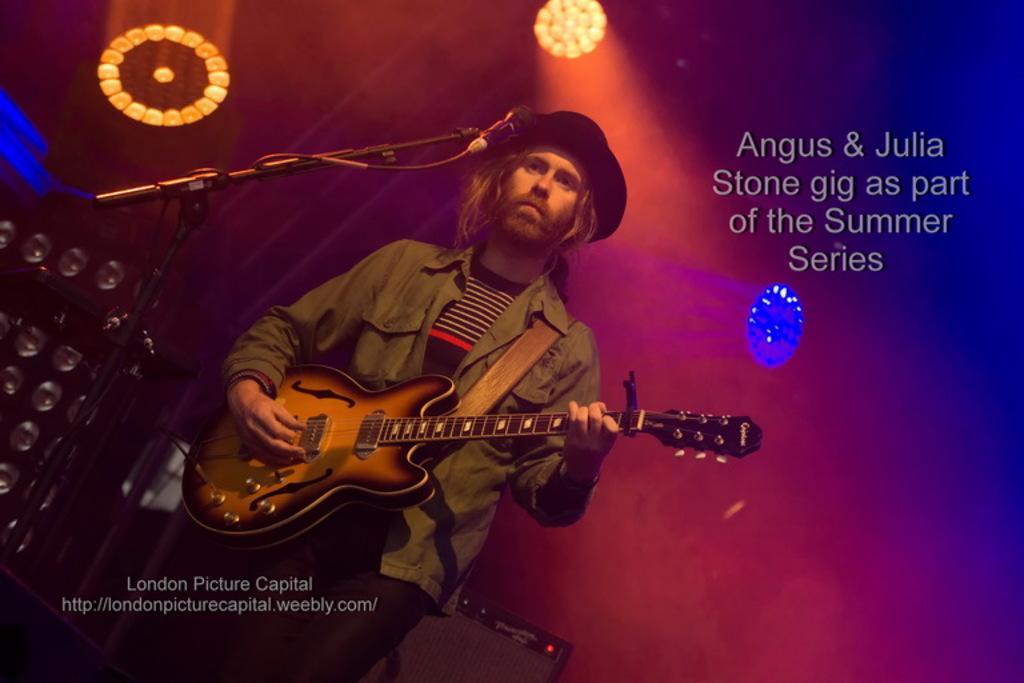Describe this image in one or two sentences. There is a man playing guitar. He wear a cap. This is mike. In the background there is a banner and these are the lights. 